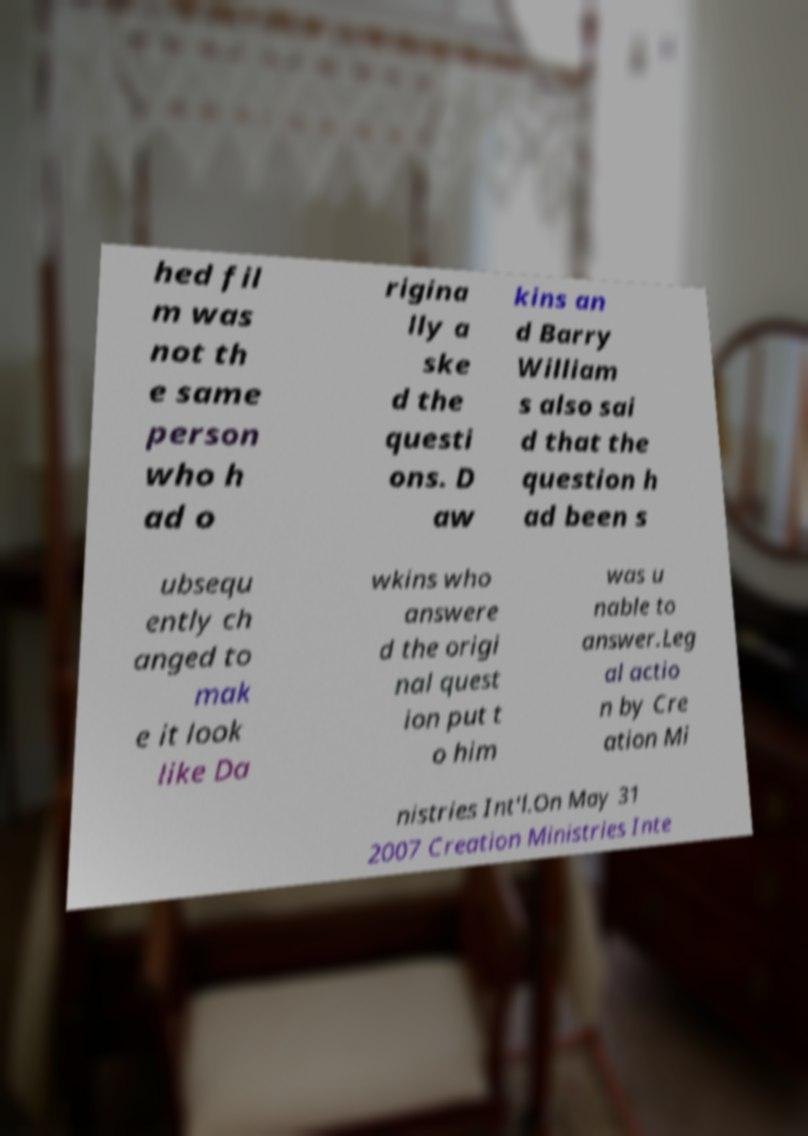I need the written content from this picture converted into text. Can you do that? hed fil m was not th e same person who h ad o rigina lly a ske d the questi ons. D aw kins an d Barry William s also sai d that the question h ad been s ubsequ ently ch anged to mak e it look like Da wkins who answere d the origi nal quest ion put t o him was u nable to answer.Leg al actio n by Cre ation Mi nistries Int'l.On May 31 2007 Creation Ministries Inte 